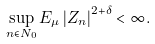Convert formula to latex. <formula><loc_0><loc_0><loc_500><loc_500>\sup _ { n \in N _ { 0 } } E _ { \mu } \left | Z _ { n } \right | ^ { 2 + \delta } < \infty .</formula> 